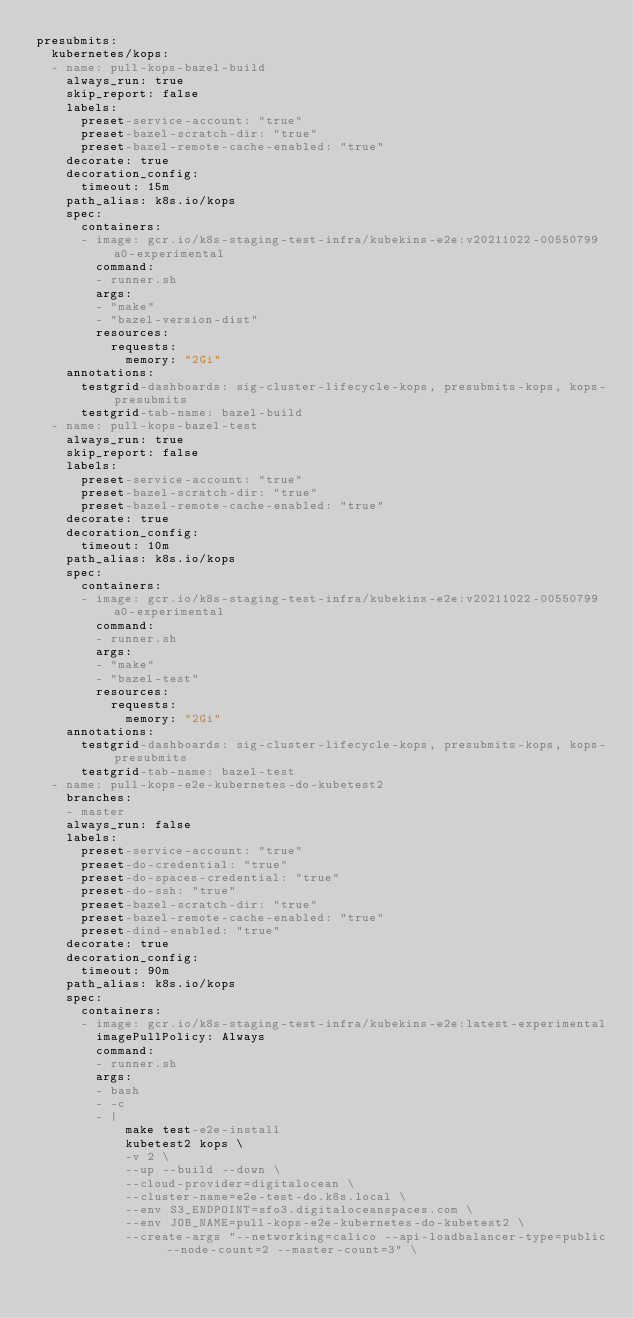Convert code to text. <code><loc_0><loc_0><loc_500><loc_500><_YAML_>presubmits:
  kubernetes/kops:
  - name: pull-kops-bazel-build
    always_run: true
    skip_report: false
    labels:
      preset-service-account: "true"
      preset-bazel-scratch-dir: "true"
      preset-bazel-remote-cache-enabled: "true"
    decorate: true
    decoration_config:
      timeout: 15m
    path_alias: k8s.io/kops
    spec:
      containers:
      - image: gcr.io/k8s-staging-test-infra/kubekins-e2e:v20211022-00550799a0-experimental
        command:
        - runner.sh
        args:
        - "make"
        - "bazel-version-dist"
        resources:
          requests:
            memory: "2Gi"
    annotations:
      testgrid-dashboards: sig-cluster-lifecycle-kops, presubmits-kops, kops-presubmits
      testgrid-tab-name: bazel-build
  - name: pull-kops-bazel-test
    always_run: true
    skip_report: false
    labels:
      preset-service-account: "true"
      preset-bazel-scratch-dir: "true"
      preset-bazel-remote-cache-enabled: "true"
    decorate: true
    decoration_config:
      timeout: 10m
    path_alias: k8s.io/kops
    spec:
      containers:
      - image: gcr.io/k8s-staging-test-infra/kubekins-e2e:v20211022-00550799a0-experimental
        command:
        - runner.sh
        args:
        - "make"
        - "bazel-test"
        resources:
          requests:
            memory: "2Gi"
    annotations:
      testgrid-dashboards: sig-cluster-lifecycle-kops, presubmits-kops, kops-presubmits
      testgrid-tab-name: bazel-test
  - name: pull-kops-e2e-kubernetes-do-kubetest2
    branches:
    - master
    always_run: false
    labels:
      preset-service-account: "true"
      preset-do-credential: "true"
      preset-do-spaces-credential: "true"
      preset-do-ssh: "true"
      preset-bazel-scratch-dir: "true"
      preset-bazel-remote-cache-enabled: "true"
      preset-dind-enabled: "true"
    decorate: true
    decoration_config:
      timeout: 90m
    path_alias: k8s.io/kops
    spec:
      containers:
      - image: gcr.io/k8s-staging-test-infra/kubekins-e2e:latest-experimental
        imagePullPolicy: Always
        command:
        - runner.sh
        args:
        - bash
        - -c
        - |
            make test-e2e-install
            kubetest2 kops \
            -v 2 \
            --up --build --down \
            --cloud-provider=digitalocean \
            --cluster-name=e2e-test-do.k8s.local \
            --env S3_ENDPOINT=sfo3.digitaloceanspaces.com \
            --env JOB_NAME=pull-kops-e2e-kubernetes-do-kubetest2 \
            --create-args "--networking=calico --api-loadbalancer-type=public --node-count=2 --master-count=3" \</code> 